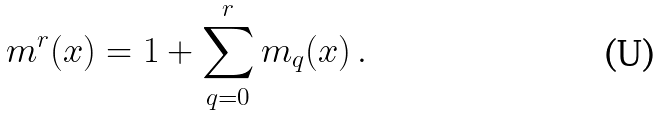Convert formula to latex. <formula><loc_0><loc_0><loc_500><loc_500>m ^ { r } ( x ) = 1 + \sum _ { q = 0 } ^ { r } m _ { q } ( x ) \, .</formula> 